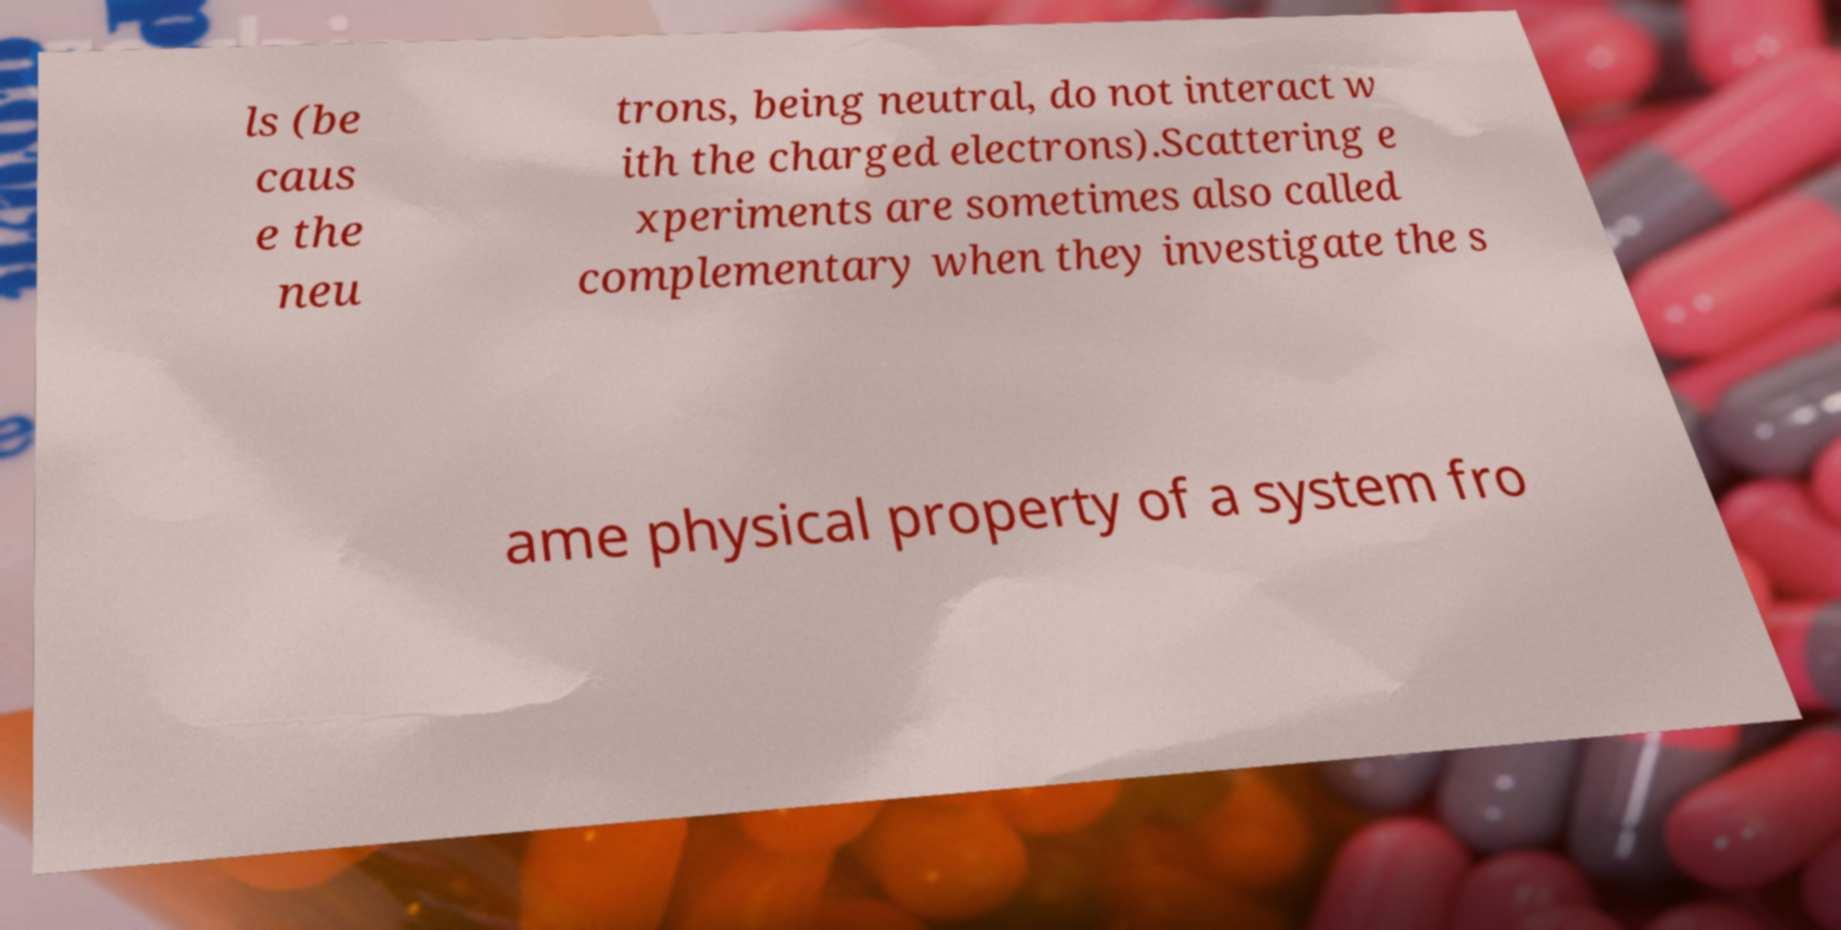Could you extract and type out the text from this image? ls (be caus e the neu trons, being neutral, do not interact w ith the charged electrons).Scattering e xperiments are sometimes also called complementary when they investigate the s ame physical property of a system fro 